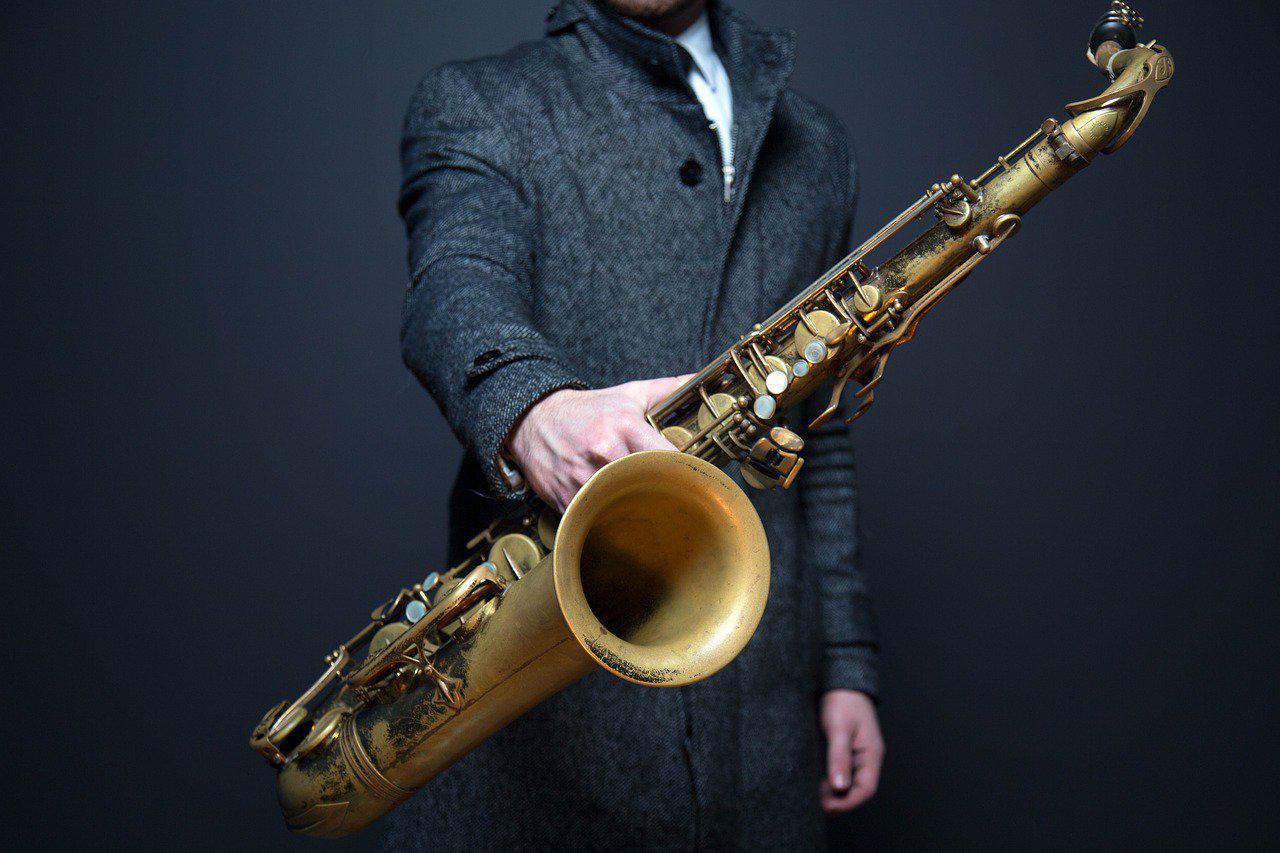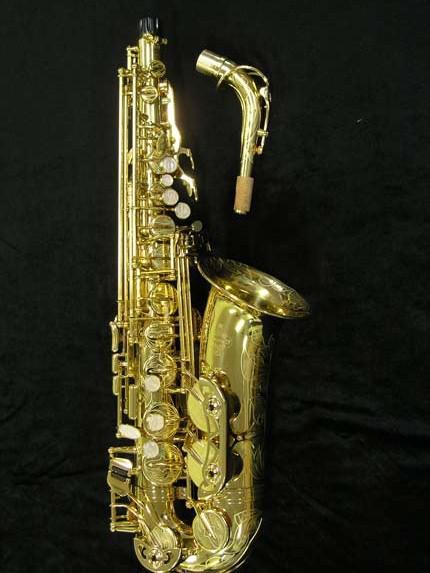The first image is the image on the left, the second image is the image on the right. For the images displayed, is the sentence "All instruments on the left hand image are displayed vertically, while they are displayed horizontally or diagonally on the right hand images." factually correct? Answer yes or no. No. The first image is the image on the left, the second image is the image on the right. Given the left and right images, does the statement "One image shows a single saxophone displayed nearly vertically, and one shows a saxophone displayed diagonally at about a 45-degree angle." hold true? Answer yes or no. Yes. 